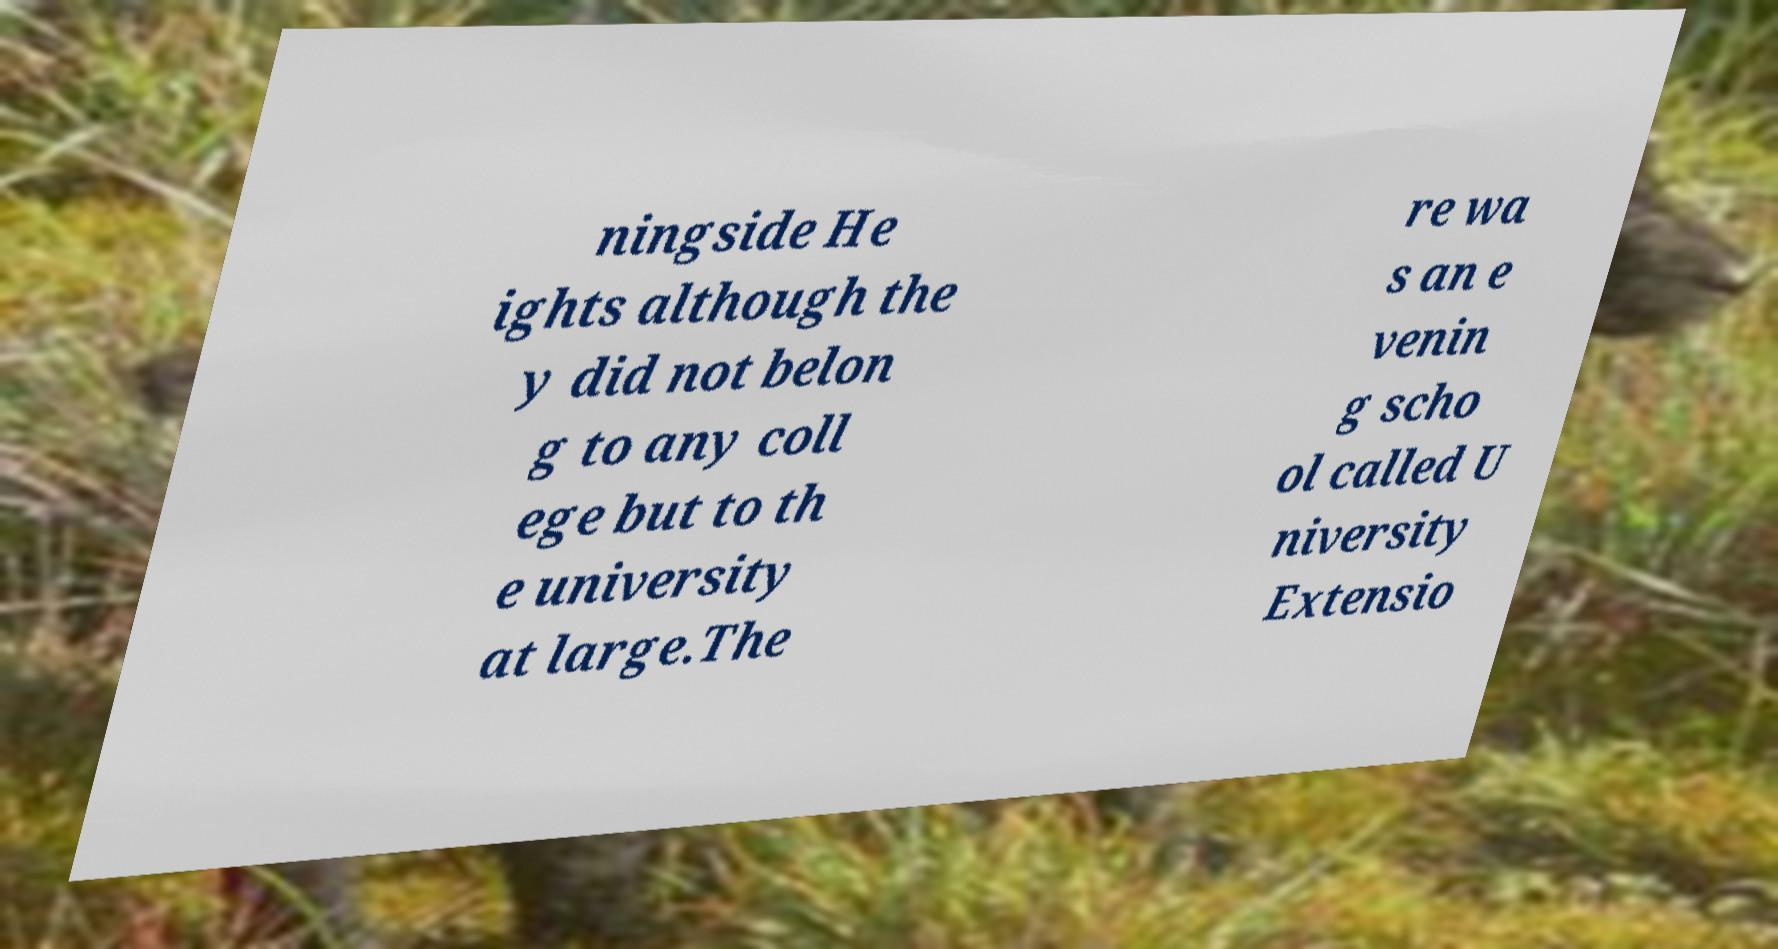Could you assist in decoding the text presented in this image and type it out clearly? ningside He ights although the y did not belon g to any coll ege but to th e university at large.The re wa s an e venin g scho ol called U niversity Extensio 